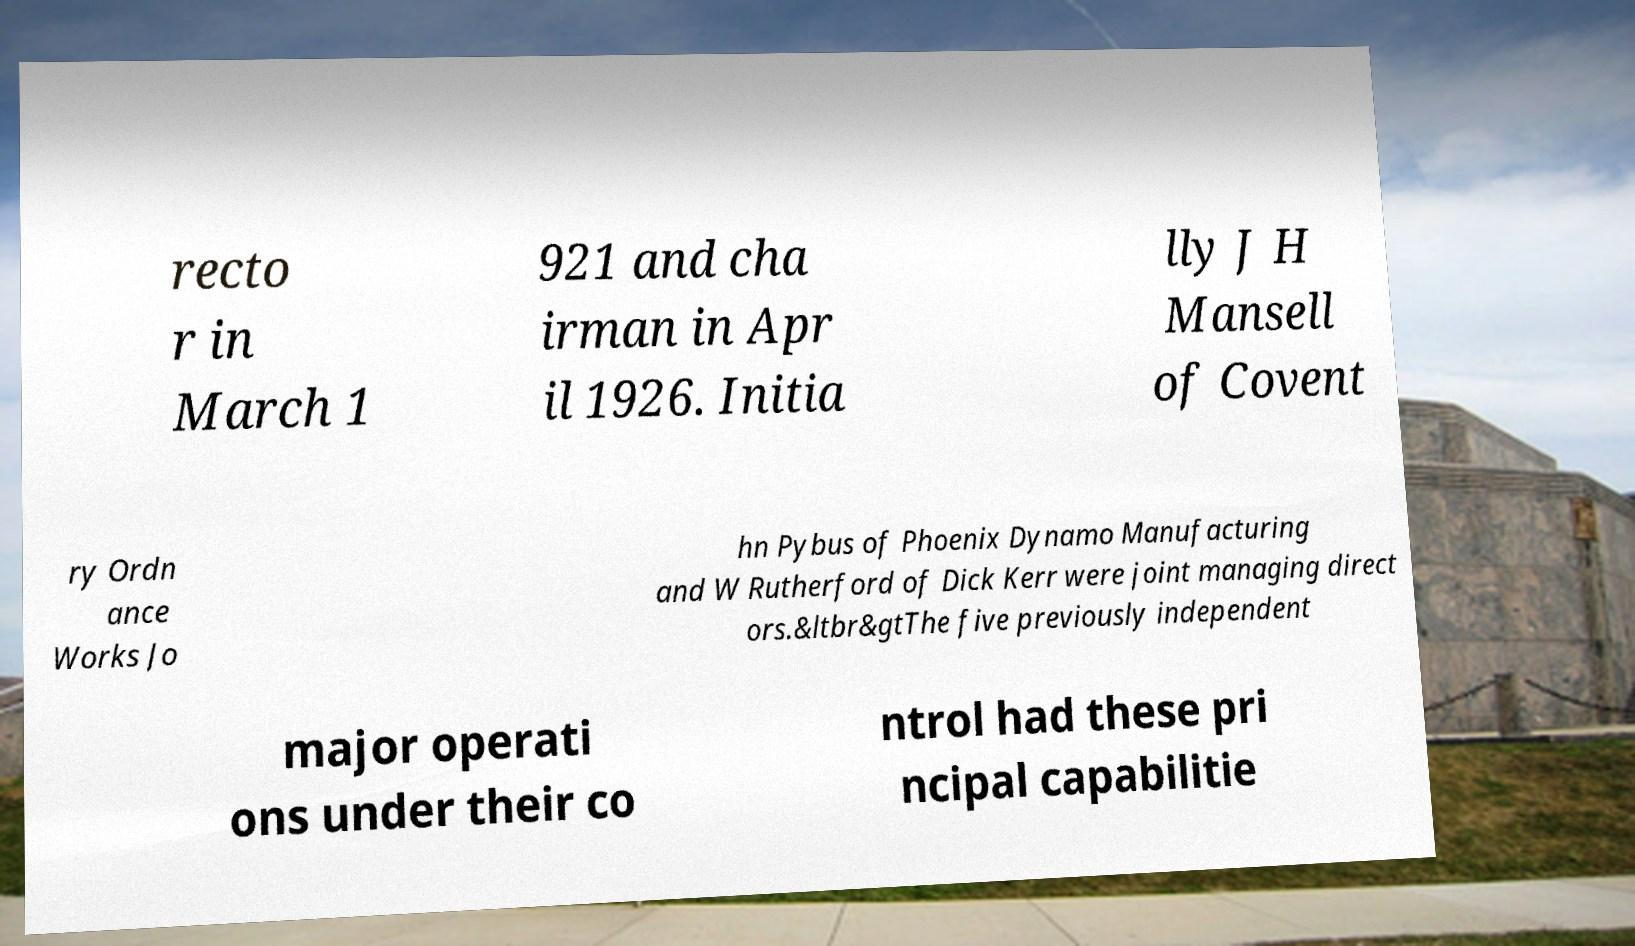Please identify and transcribe the text found in this image. recto r in March 1 921 and cha irman in Apr il 1926. Initia lly J H Mansell of Covent ry Ordn ance Works Jo hn Pybus of Phoenix Dynamo Manufacturing and W Rutherford of Dick Kerr were joint managing direct ors.&ltbr&gtThe five previously independent major operati ons under their co ntrol had these pri ncipal capabilitie 